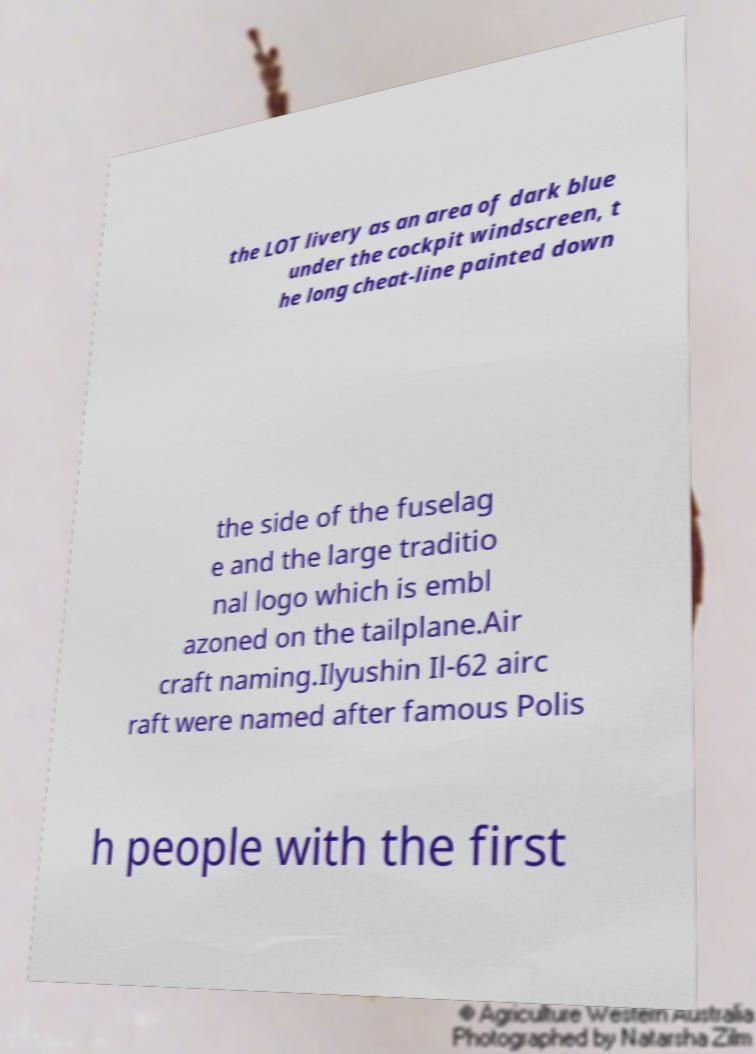Could you assist in decoding the text presented in this image and type it out clearly? the LOT livery as an area of dark blue under the cockpit windscreen, t he long cheat-line painted down the side of the fuselag e and the large traditio nal logo which is embl azoned on the tailplane.Air craft naming.Ilyushin Il-62 airc raft were named after famous Polis h people with the first 